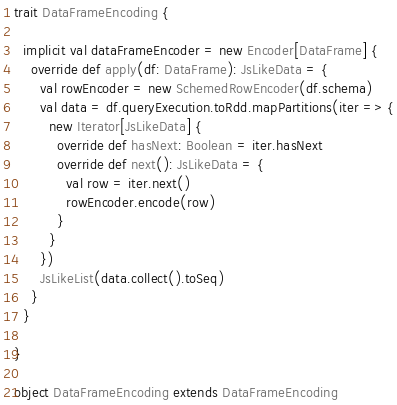<code> <loc_0><loc_0><loc_500><loc_500><_Scala_>
trait DataFrameEncoding {

  implicit val dataFrameEncoder = new Encoder[DataFrame] {
    override def apply(df: DataFrame): JsLikeData = {
      val rowEncoder = new SchemedRowEncoder(df.schema)
      val data = df.queryExecution.toRdd.mapPartitions(iter => {
        new Iterator[JsLikeData] {
          override def hasNext: Boolean = iter.hasNext
          override def next(): JsLikeData = {
            val row = iter.next()
            rowEncoder.encode(row)
          }
        }
      })
      JsLikeList(data.collect().toSeq)
    }
  }

}

object DataFrameEncoding extends DataFrameEncoding
</code> 